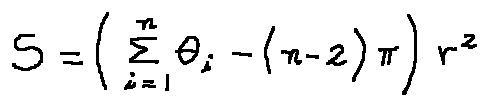<formula> <loc_0><loc_0><loc_500><loc_500>S = ( \sum \lim i t s _ { i = 1 } ^ { n } \theta _ { i } - ( n - 2 ) \pi ) r ^ { 2 }</formula> 